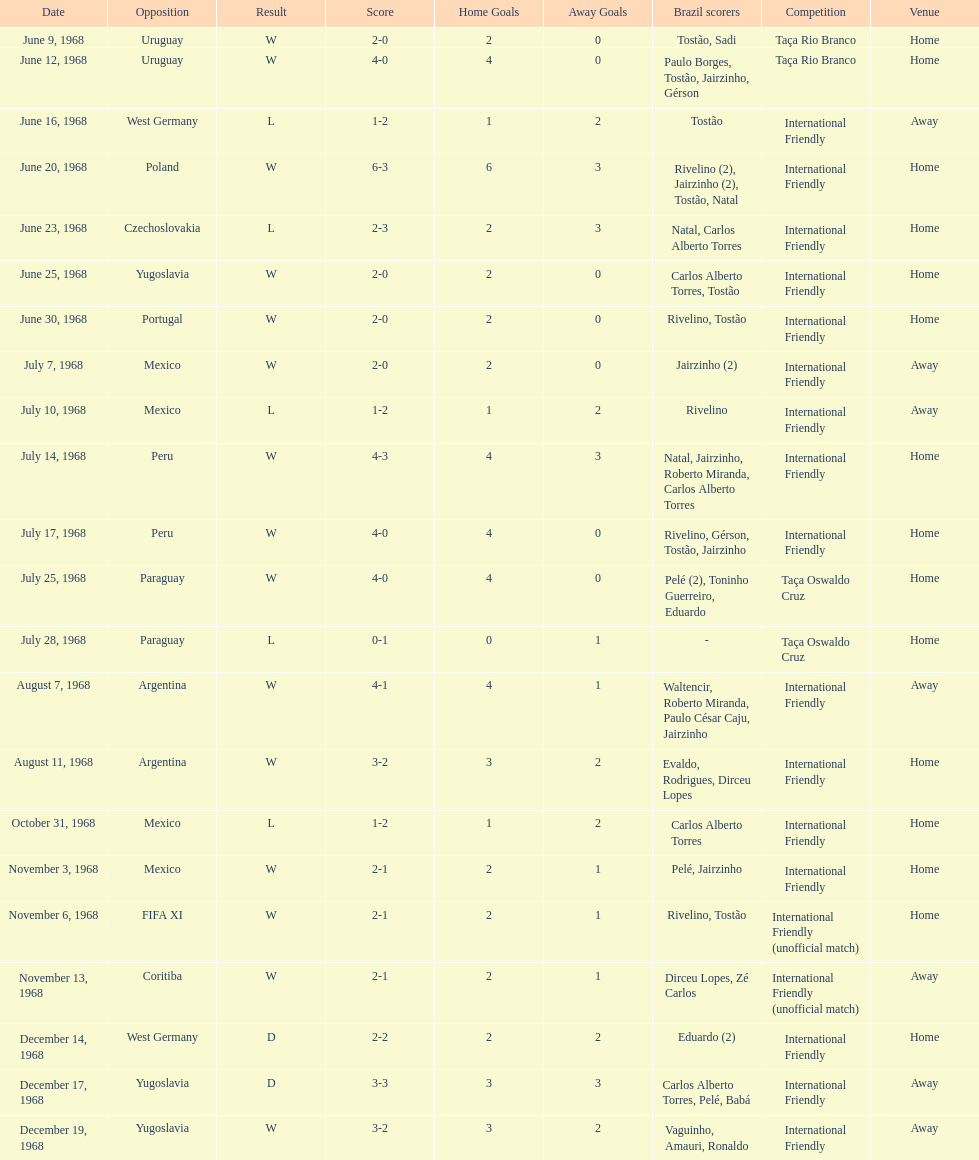In the international friendly competition, what is the total number of matches played between brazil and argentina? 2. 